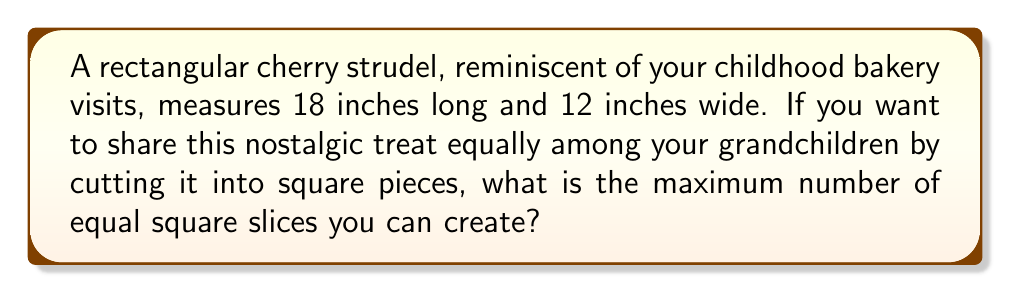Can you solve this math problem? Let's approach this step-by-step:

1) To get equal square slices, the side length of each square must be a common factor of both the length and width of the strudel.

2) The dimensions of the strudel are 18 inches by 12 inches.

3) We need to find the greatest common divisor (GCD) of 18 and 12.

4) To find the GCD, let's list the factors of each number:
   Factors of 18: 1, 2, 3, 6, 9, 18
   Factors of 12: 1, 2, 3, 4, 6, 12

5) The greatest number that appears in both lists is 6.

6) So, the largest possible square slice will have a side length of 6 inches.

7) To find the number of slices, we divide the area of the strudel by the area of one slice:

   $$ \text{Number of slices} = \frac{\text{Area of strudel}}{\text{Area of one slice}} $$

   $$ = \frac{18 \times 12}{6 \times 6} = \frac{216}{36} = 6 $$

Therefore, you can cut the strudel into 6 equal square slices.
Answer: 6 slices 